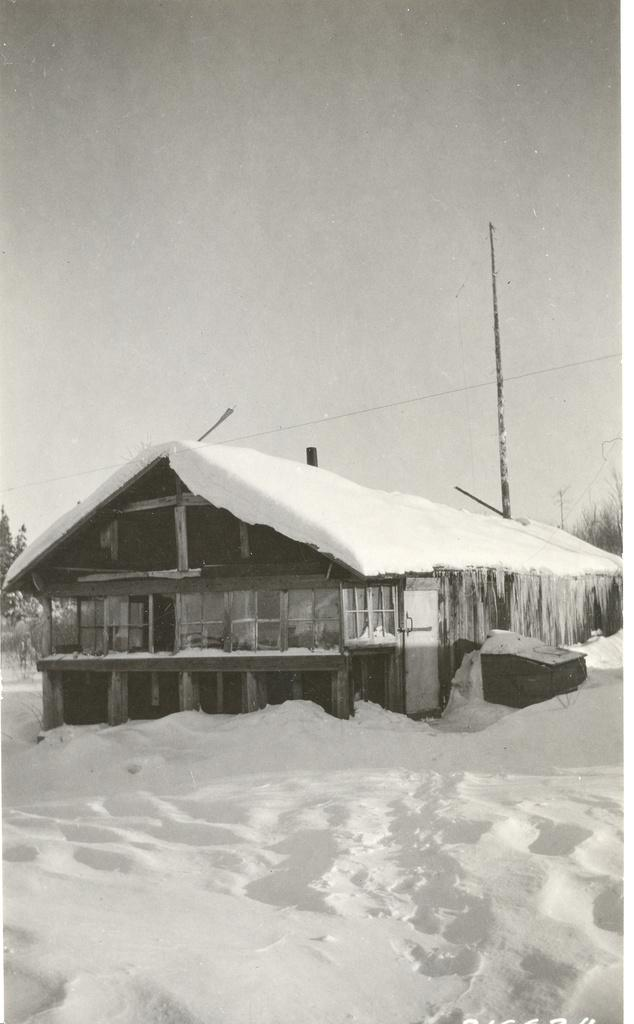What is the color scheme of the image? The image is in black and white. What type of weather is depicted in the image? There is snow in the image. What structure is covered with snow in the image? There is a wooden house covered with snow in the image. What can be seen in the background of the image? There are trees and the sky visible in the background of the image. What type of tub is visible in the image? There is no tub present in the image. What kind of machine can be seen operating in the snow? There is no machine visible in the image; it only features a wooden house and snow. 